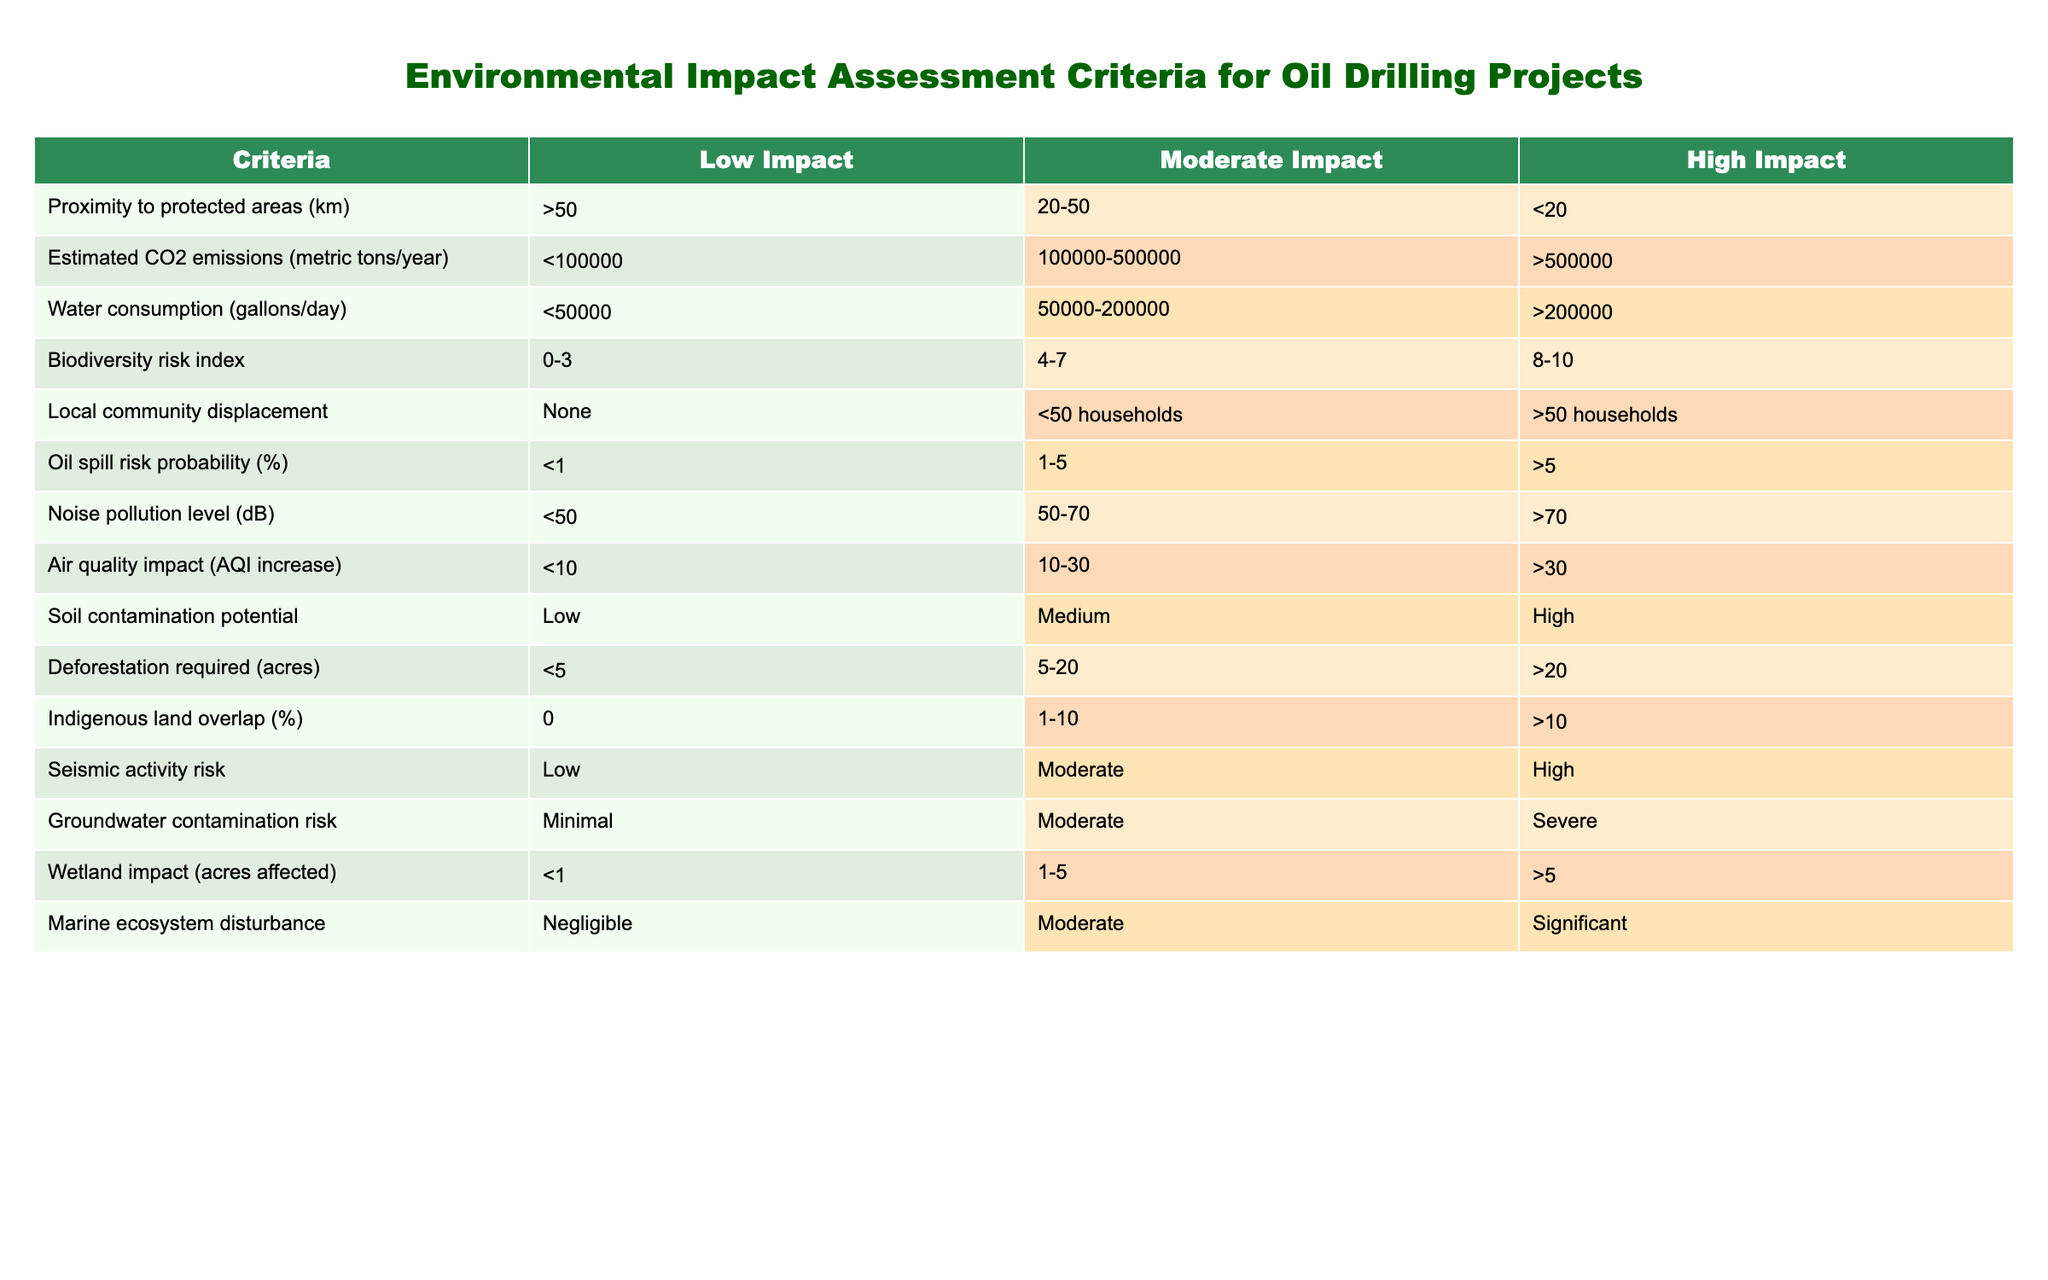What is the maximum proximity to protected areas for low impact? The table states that for low impact, the proximity to protected areas should be greater than 50 km.
Answer: >50 How many gallons of water consumption correspond to moderate impact? According to the table, moderate impact corresponds to water consumption between 50,000 and 200,000 gallons per day.
Answer: 50000-200000 Is a biodiversity risk index of 5 categorized as high impact? The table categorizes a biodiversity risk index of 4-7 as moderate impact, and 8-10 as high impact. Therefore, a score of 5 is not high impact.
Answer: No What is the air quality impact range for high impact projects? The air quality impact for high impact projects is defined as greater than 30. This is taken directly from the provided table.
Answer: >30 What is the difference in oil spill risk probability between low impact and high impact? The oil spill risk probabilities for low impact and high impact are <1% and >5%, respectively. To find the difference, we can say that the high impact has a minimum of 5% probability, making the difference more than 5%.
Answer: >5 Is it true that the soil contamination potential for moderate impact is categorized as high? The table indicates that for moderate impact, the soil contamination potential is categorized as medium, not high. Therefore, the statement is false.
Answer: No How many acres must be deforested for a project to be considered high impact? The table specifies that high impact projects require more than 20 acres of deforestation, which corresponds directly from the data.
Answer: >20 If we consider the risks of groundwater contamination, what are the potential risk levels? The groundwater contamination risk levels range from minimal for low impact, to moderate for moderate impact, and severe for high impact. We determine this by looking at the categorized values provided in the table.
Answer: Minimal, Moderate, Severe If an oil drilling project impacts 2 acres of wetland, what is its impact level? Since the table states that low impact is characterized by less than 1 acre affected, a project impacting 2 acres would fall into the moderate impact category (1-5 acres affected) according to the table classifications.
Answer: Moderate 